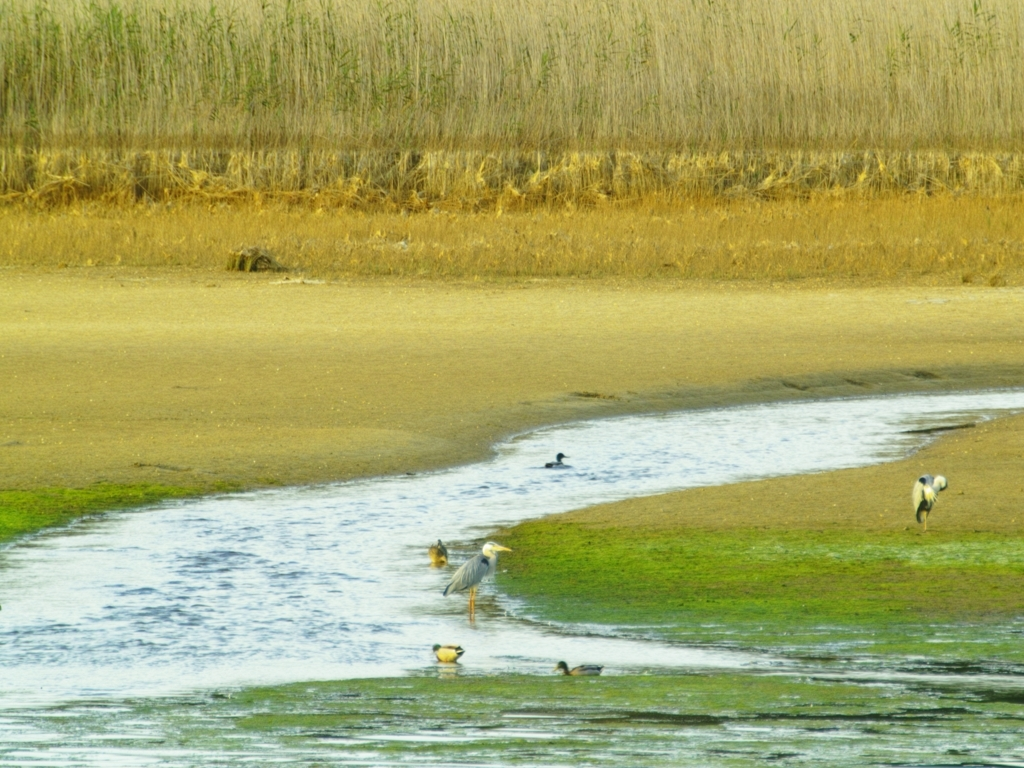What is the overall clarity of the image? The overall clarity of the image is moderate but not high; while the foreground is relatively clear, showing birds along the water's edge, the background details are somewhat obscured and less distinct. The image appears slightly over-exposed which affects the sharpness of the distant features. 